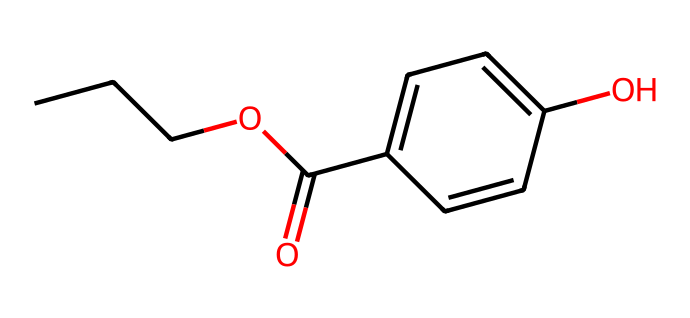What is the name of this chemical? The SMILES representation translates to a molecular structure that indicates the name of the compound is propylparaben, which is a well-known preservative used in personal care items.
Answer: propylparaben How many carbon atoms are in the structure? By analyzing the SMILES, I can see there are six carbon atoms indicated (three from the propyl group and three from the aromatic ring). Counting the carbon symbols in the SMILES confirms this.
Answer: six What functional group is present in propylparaben? The SMILES contains a carboxylate ester functional group represented by the presence of both carbonyl (C=O) and ether (C-O-C) connections. These structures confirm the nature of the functional group.
Answer: ester What is the molecular formula of propylparaben? Based on the count of carbon (C), hydrogen (H), and oxygen (O) atoms in the structure, I determine the molecular formula is C10H12O3. This is verified by adding the number of each type of atom represented in the SMILES.
Answer: C10H12O3 How many rings are present in the molecular structure? The SMILES shows a cyclic structure derived from the benzene ring, which consists of six carbon atoms forming one ring. Hence, there is only one notable ring in propylparaben.
Answer: one What property allows propylparaben to act as a preservative? The presence of the hydroxyl (-OH) groups in the structure facilitates its function as a preservative by providing antimicrobial activity. This is a common chemical property of compounds with similar structures.
Answer: antimicrobial activity 